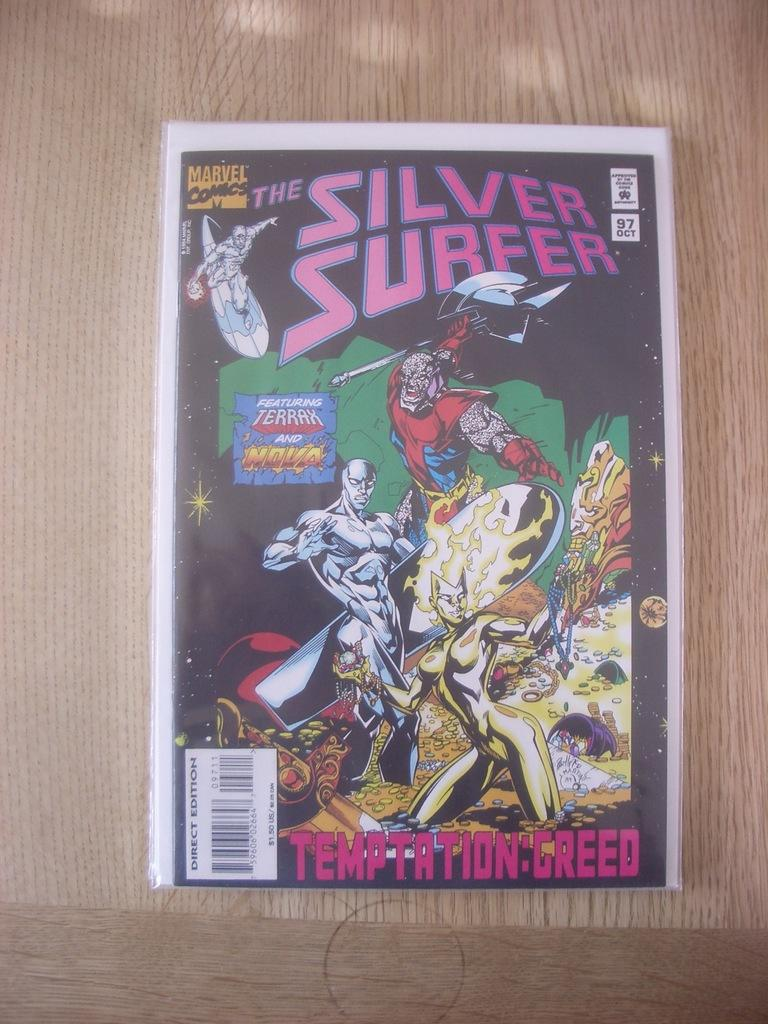Provide a one-sentence caption for the provided image. The brand new Marvel comic Silver Surfer has been released. 